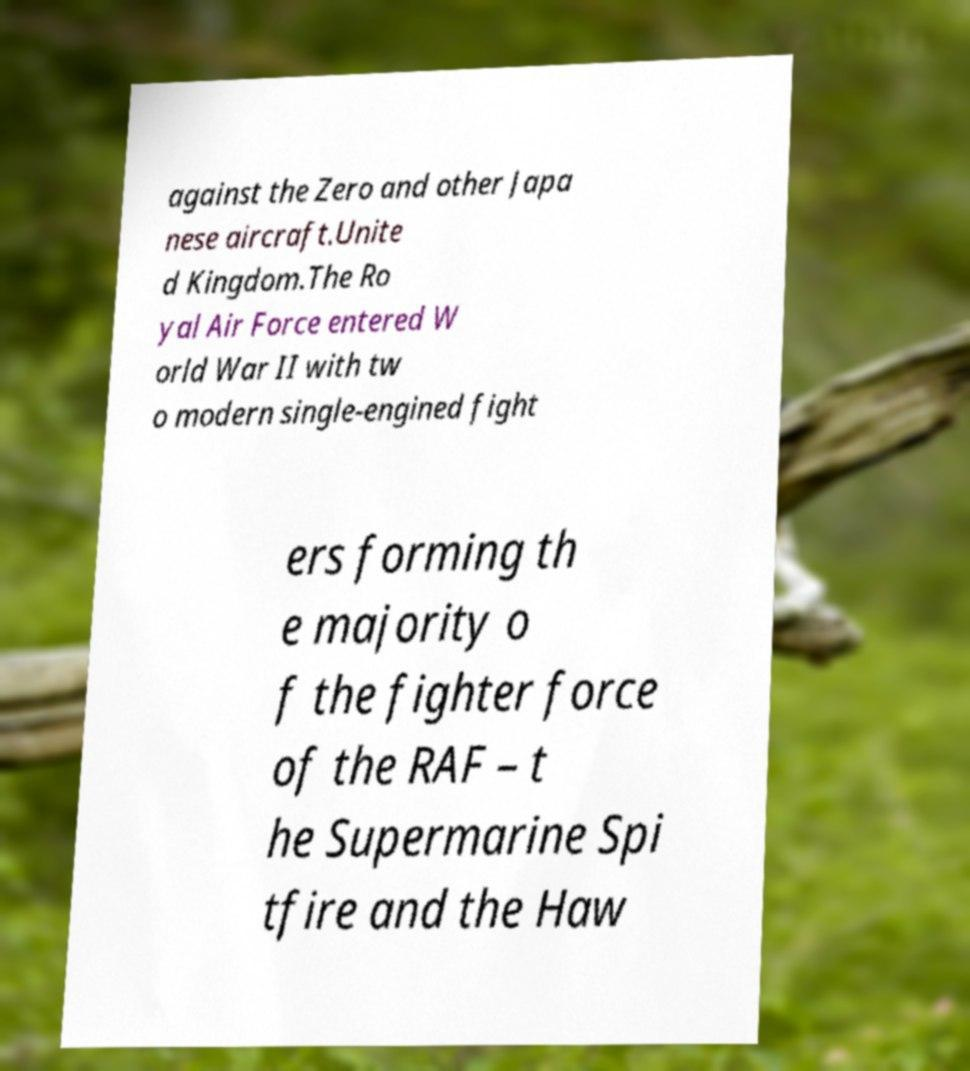Could you extract and type out the text from this image? against the Zero and other Japa nese aircraft.Unite d Kingdom.The Ro yal Air Force entered W orld War II with tw o modern single-engined fight ers forming th e majority o f the fighter force of the RAF – t he Supermarine Spi tfire and the Haw 